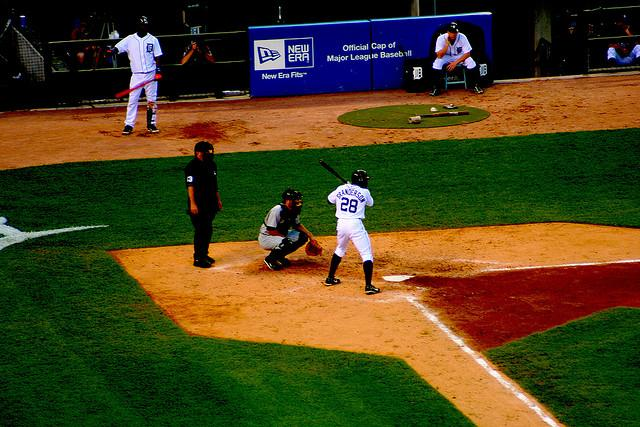The person wearing what color of shirt officiates the game? black 